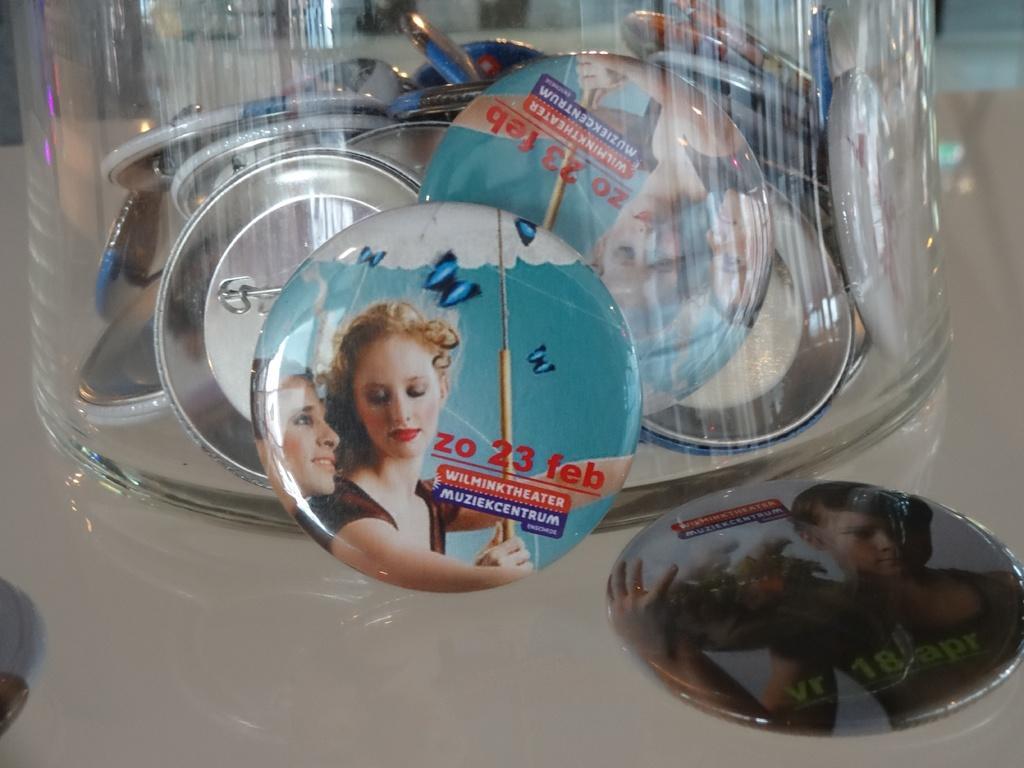In one or two sentences, can you explain what this image depicts? In this image, we can see a glass, in the glass, we can see some coins, on the coin, we can see pictures of people and some text written on the coin. On the right side of the image, we can see pictures of an image on the coin. On the left side, we can also see one edge of a coin. 